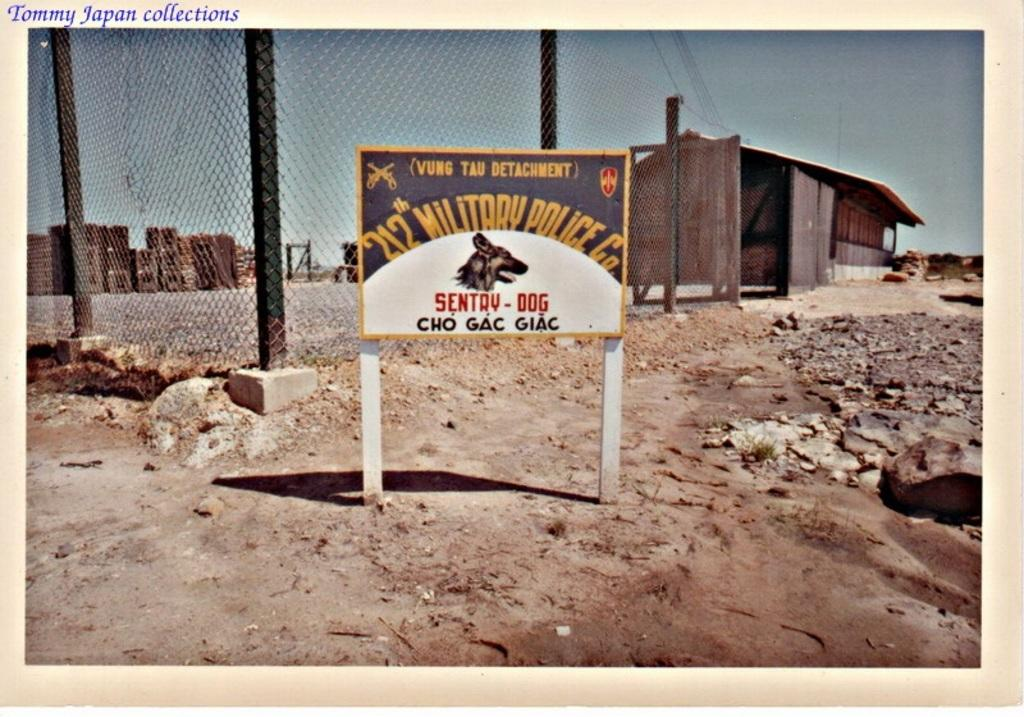What is the main object in the image? There is a board in the image. What can be seen in the background of the image? There is a railing and a shed visible in the background of the image. What part of the natural environment is visible in the image? The sky is visible in the background of the image. What type of leather is being used to make the waves in the image? There are no waves or leather present in the image; it features a board, railing, shed, and sky. 